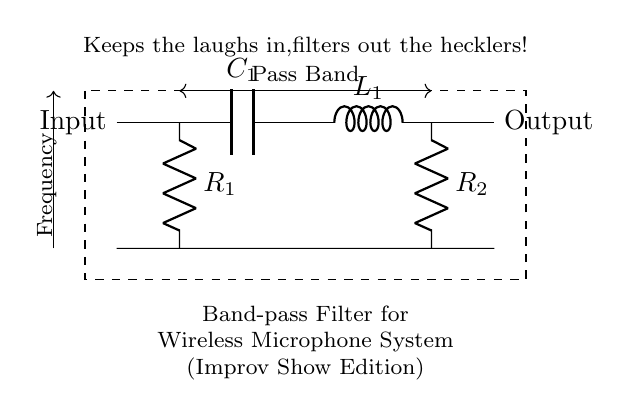What type of filter is shown in this circuit? The circuit diagram is labeled as a Band-pass Filter, which indicates that it allows signals within a certain frequency range to pass while attenuating signals outside that range.
Answer: Band-pass Filter What are the components used in this circuit? The circuit consists of capacitors, inductors, and resistors, specifically noted as C1, L1, R1, and R2. The diagram visually identifies these components by their respective symbols.
Answer: Capacitor, Inductor, Resistor What is the purpose of R1 and R2 in the diagram? R1 and R2 are resistors that help shape the frequency response of the band-pass filter. They influence the filter's bandwidth and quality factor by controlling the circuit's gain and damping.
Answer: Shape frequency response What does the dashed rectangle represent? The dashed rectangle encompasses the components, indicating they work together as a single unit, which in this case is the band-pass filter for wireless microphone systems.
Answer: Band-pass filter unit In what context is this filter particularly useful? The diagram notes it is designed for wireless microphone systems used in improv shows, suggesting it is tailored to enhance audio performance in live environments where clarity is essential.
Answer: Improv shows What does the label "Keeps the laughs in, filters out the hecklers!" imply? This phrase humorously conveys the filter's role in ensuring that only desired frequencies (like laughter from the audience) are amplified while unwanted noise (like heckling) is minimized, making it fitting for live performances.
Answer: Humorously implies selective audio enhancement 